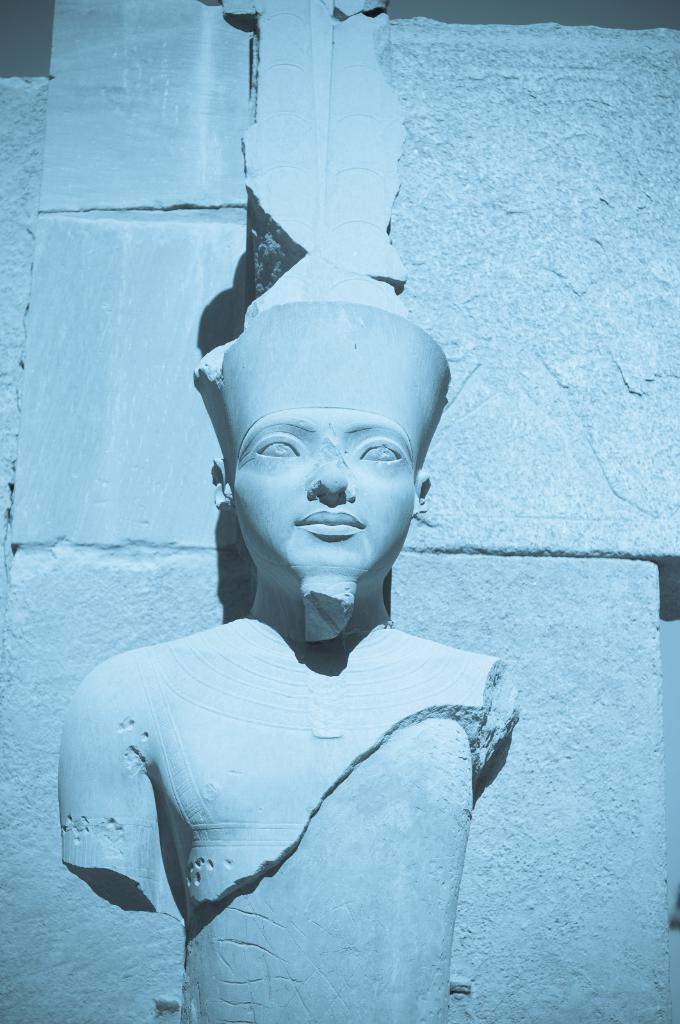How would you summarize this image in a sentence or two? Here in this picture we can see a statue being carved on the wall over there. 